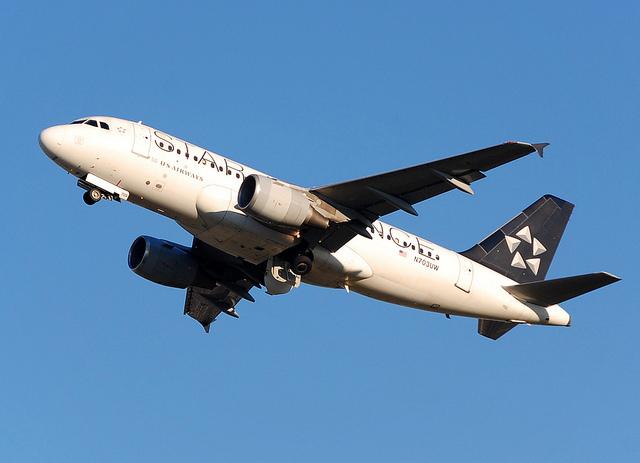How many jets does the plane have?
Short answer required. 2. What color is the plane`?
Be succinct. White. What color is the sky?
Write a very short answer. Blue. Is this a jet airplane?
Concise answer only. Yes. 